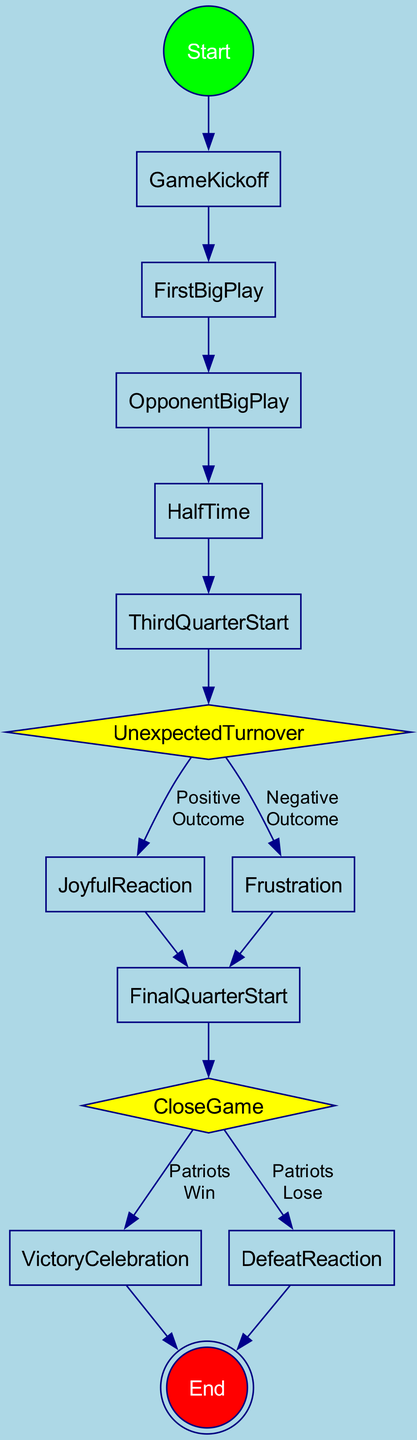What's the first action after the game starts? The first action in the diagram after the game starts is "GameKickoff". This is the direct connection from the start node "StartGame".
Answer: GameKickoff How many decision points are there in the diagram? There are two decision points in the diagram, specifically "UnexpectedTurnover" and "CloseGame" as identified in the flow of actions.
Answer: 2 What happens after an opponent makes a big play? After an opponent makes a big play, the next step in the diagram is "HalfTime". This indicates the flow of emotional states following a significant opposing event.
Answer: HalfTime During what part of the game do fans experience renewed energy and hope? Fans experience renewed energy and hope during the "ThirdQuarterStart", which is the action that follows halftime in the diagram.
Answer: ThirdQuarterStart What is the final action if the Patriots win? The final action after a Patriots win is "VictoryCelebration", as shown in the diagram after encountering the win condition.
Answer: VictoryCelebration What emotional state is reached if there is a negative outcome from a turnover? If there is a negative outcome from a turnover, the emotional state will be "Frustration", which follows the "UnexpectedTurnover" decision point for negative outcomes.
Answer: Frustration Which two actions follow after a joyful reaction? The two actions that follow a joyful reaction are "FinalQuarterStart", since it shows the continuity of the game after a positive emotional spike.
Answer: FinalQuarterStart What is the relationship between "CloseGame" and "VictoryCelebration"? The relationship is that "CloseGame" leads to "VictoryCelebration" if the Patriots win. This is a direct edge in the flow, indicating the outcome based on the game situation.
Answer: CloseGame leads to VictoryCelebration What is the starting point of the activity diagram? The starting point of the activity diagram is "StartGame", which marks the initiation of the emotional journey during the game.
Answer: StartGame 